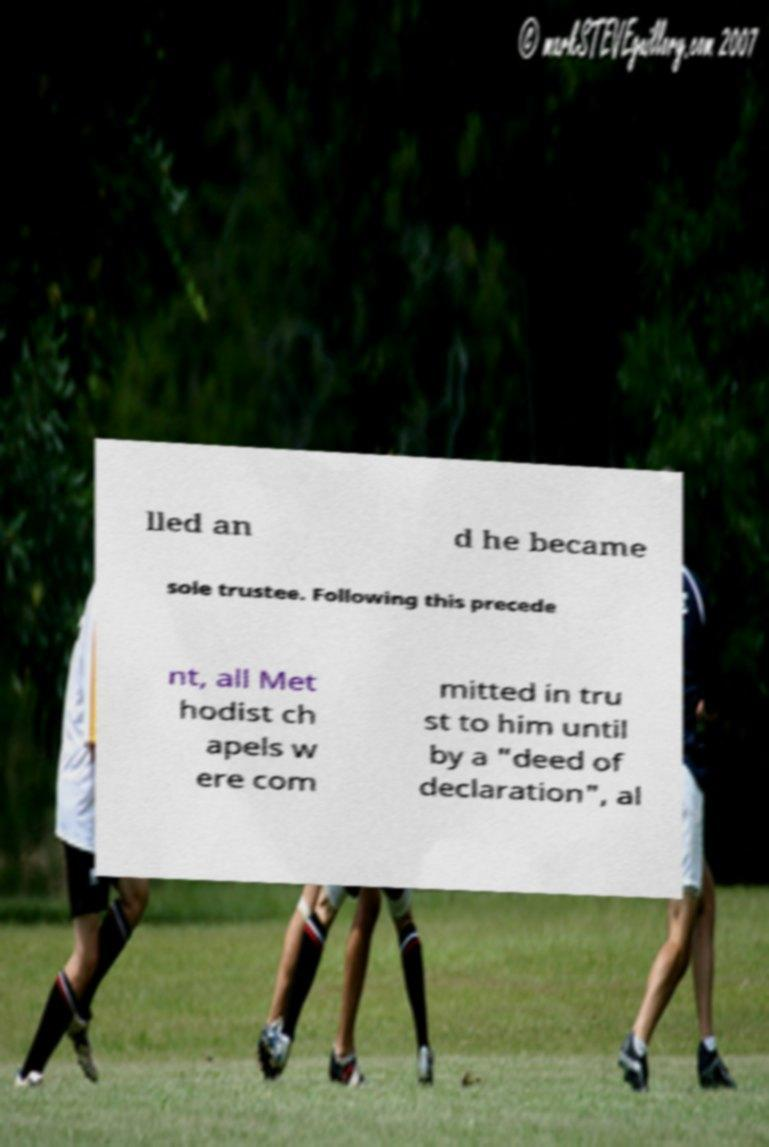Please identify and transcribe the text found in this image. lled an d he became sole trustee. Following this precede nt, all Met hodist ch apels w ere com mitted in tru st to him until by a "deed of declaration", al 